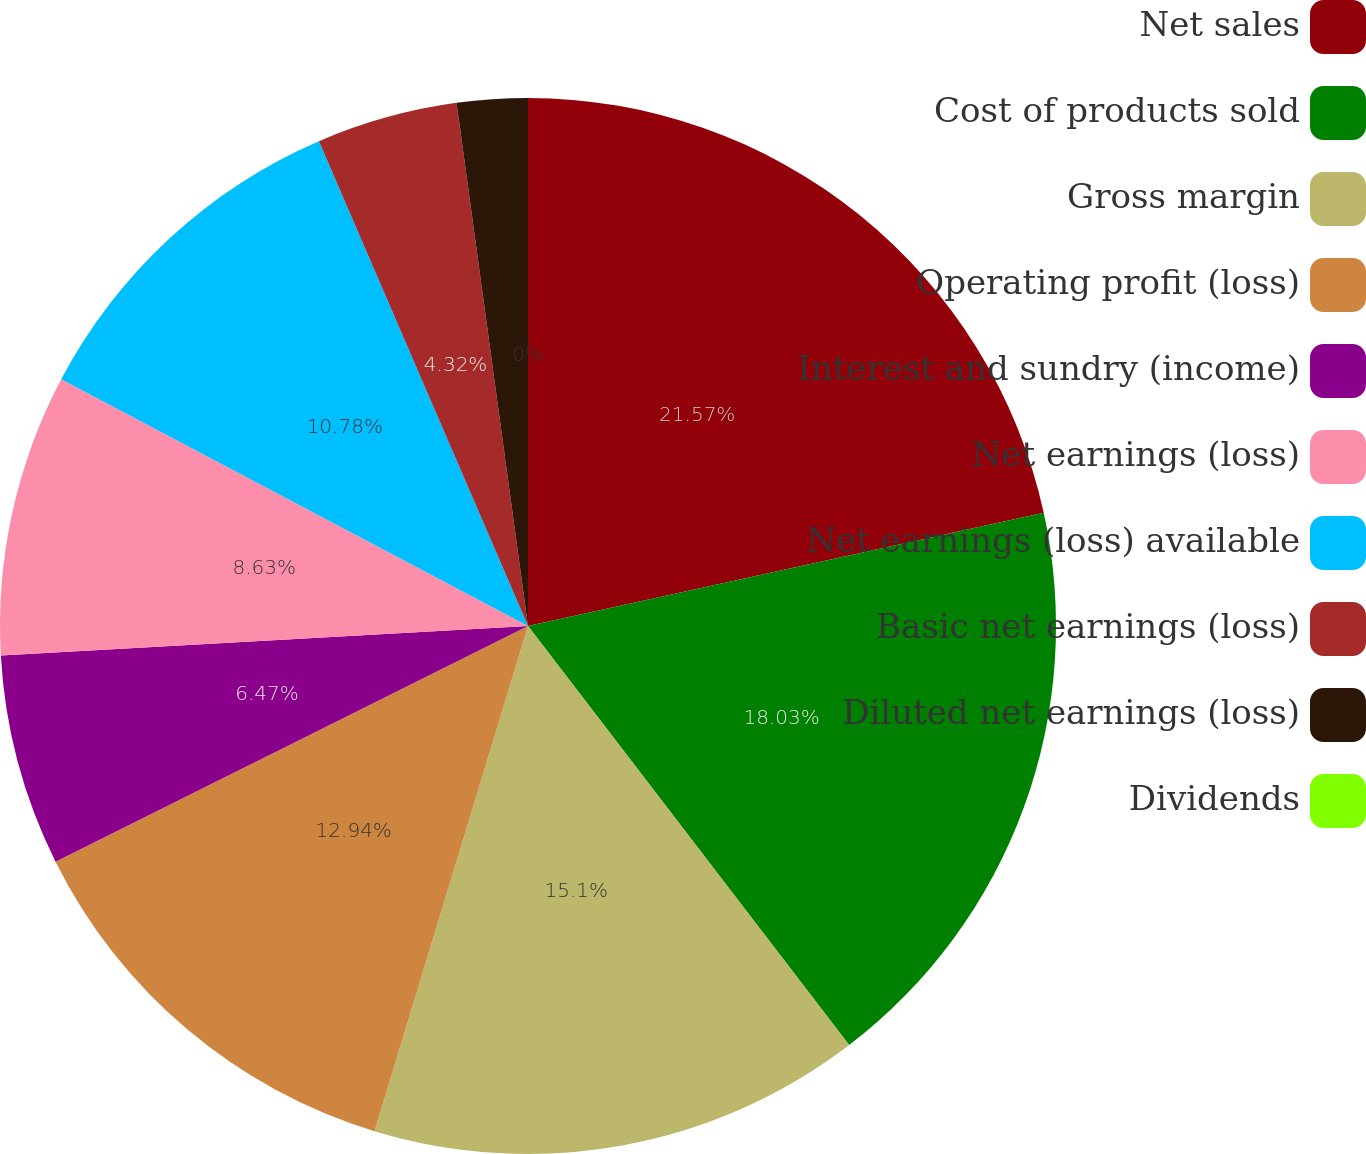<chart> <loc_0><loc_0><loc_500><loc_500><pie_chart><fcel>Net sales<fcel>Cost of products sold<fcel>Gross margin<fcel>Operating profit (loss)<fcel>Interest and sundry (income)<fcel>Net earnings (loss)<fcel>Net earnings (loss) available<fcel>Basic net earnings (loss)<fcel>Diluted net earnings (loss)<fcel>Dividends<nl><fcel>21.56%<fcel>18.03%<fcel>15.1%<fcel>12.94%<fcel>6.47%<fcel>8.63%<fcel>10.78%<fcel>4.32%<fcel>2.16%<fcel>0.0%<nl></chart> 